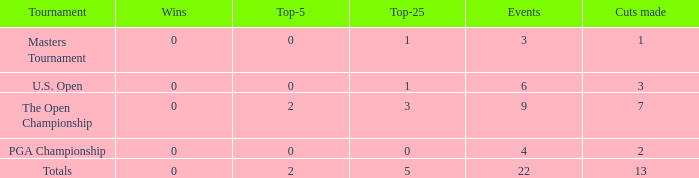What is the average number of cuts made for events with 0 top-5s? None. 